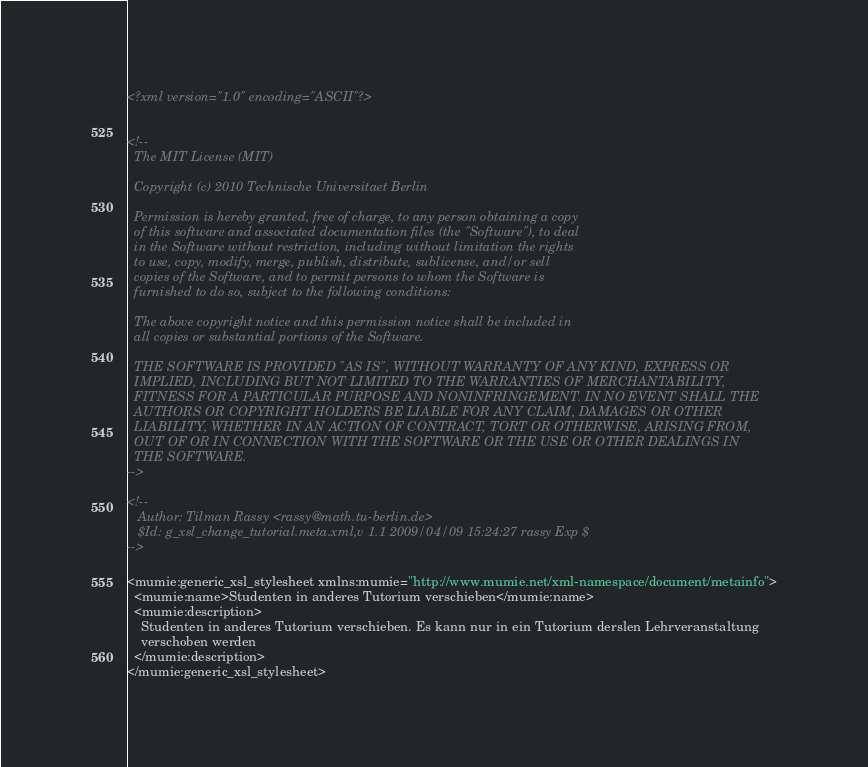Convert code to text. <code><loc_0><loc_0><loc_500><loc_500><_XML_><?xml version="1.0" encoding="ASCII"?>


<!--
  The MIT License (MIT)
  
  Copyright (c) 2010 Technische Universitaet Berlin
  
  Permission is hereby granted, free of charge, to any person obtaining a copy
  of this software and associated documentation files (the "Software"), to deal
  in the Software without restriction, including without limitation the rights
  to use, copy, modify, merge, publish, distribute, sublicense, and/or sell
  copies of the Software, and to permit persons to whom the Software is
  furnished to do so, subject to the following conditions:
  
  The above copyright notice and this permission notice shall be included in
  all copies or substantial portions of the Software.
  
  THE SOFTWARE IS PROVIDED "AS IS", WITHOUT WARRANTY OF ANY KIND, EXPRESS OR
  IMPLIED, INCLUDING BUT NOT LIMITED TO THE WARRANTIES OF MERCHANTABILITY,
  FITNESS FOR A PARTICULAR PURPOSE AND NONINFRINGEMENT. IN NO EVENT SHALL THE
  AUTHORS OR COPYRIGHT HOLDERS BE LIABLE FOR ANY CLAIM, DAMAGES OR OTHER
  LIABILITY, WHETHER IN AN ACTION OF CONTRACT, TORT OR OTHERWISE, ARISING FROM,
  OUT OF OR IN CONNECTION WITH THE SOFTWARE OR THE USE OR OTHER DEALINGS IN
  THE SOFTWARE.
-->

<!--
   Author: Tilman Rassy <rassy@math.tu-berlin.de>
   $Id: g_xsl_change_tutorial.meta.xml,v 1.1 2009/04/09 15:24:27 rassy Exp $
-->

<mumie:generic_xsl_stylesheet xmlns:mumie="http://www.mumie.net/xml-namespace/document/metainfo">
  <mumie:name>Studenten in anderes Tutorium verschieben</mumie:name>
  <mumie:description>
    Studenten in anderes Tutorium verschieben. Es kann nur in ein Tutorium derslen Lehrveranstaltung
    verschoben werden
  </mumie:description>
</mumie:generic_xsl_stylesheet>
</code> 